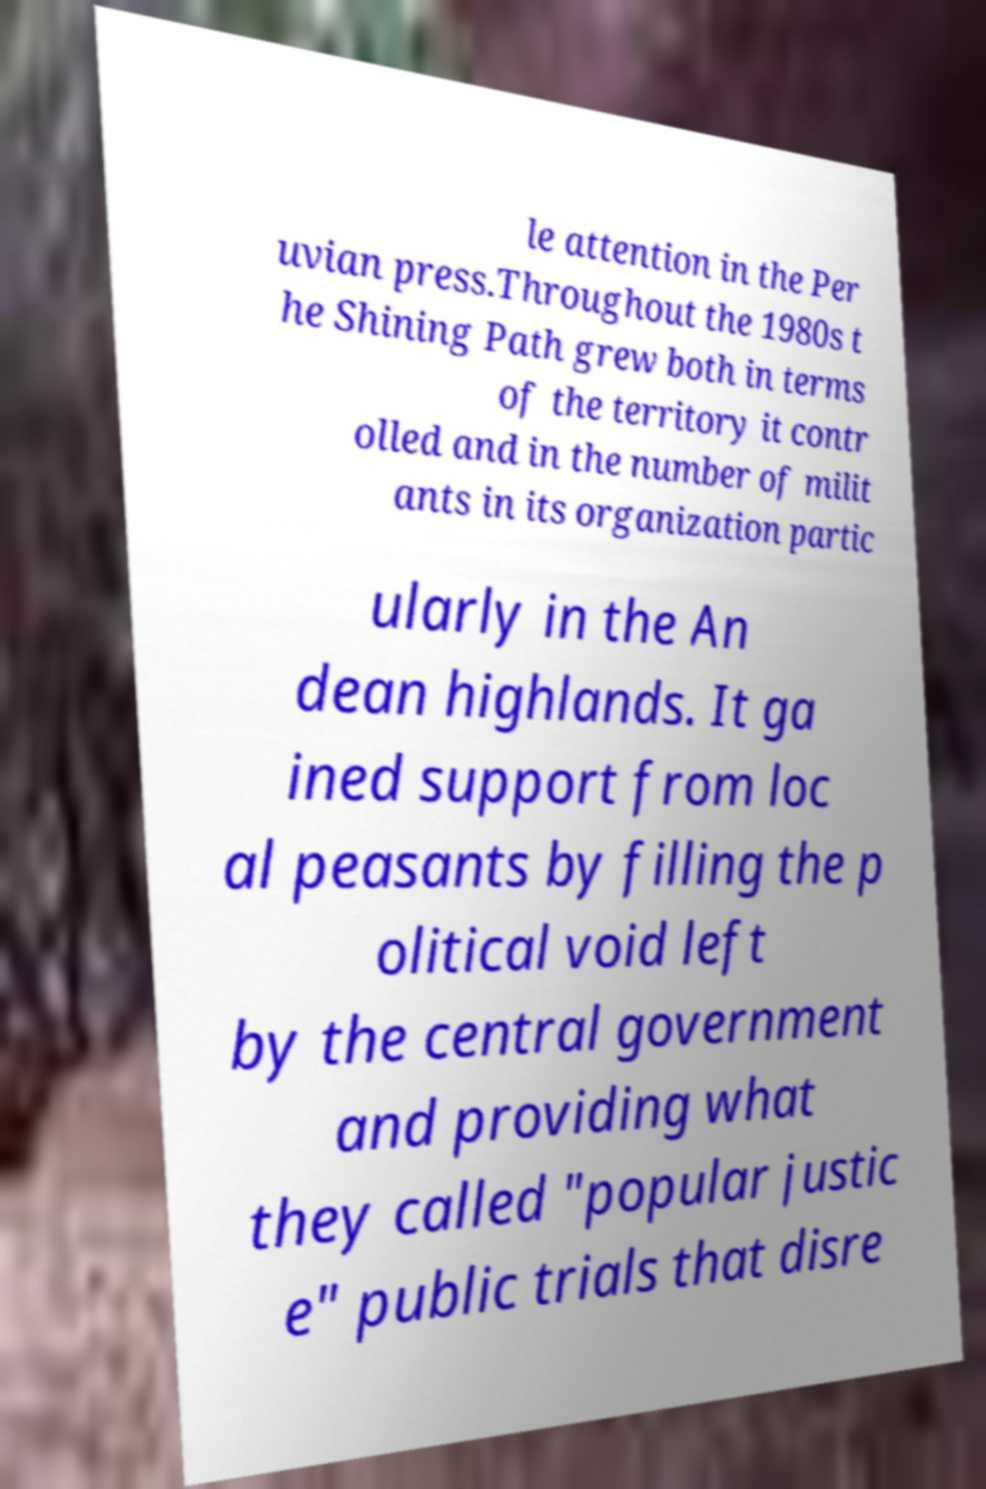Can you accurately transcribe the text from the provided image for me? le attention in the Per uvian press.Throughout the 1980s t he Shining Path grew both in terms of the territory it contr olled and in the number of milit ants in its organization partic ularly in the An dean highlands. It ga ined support from loc al peasants by filling the p olitical void left by the central government and providing what they called "popular justic e" public trials that disre 